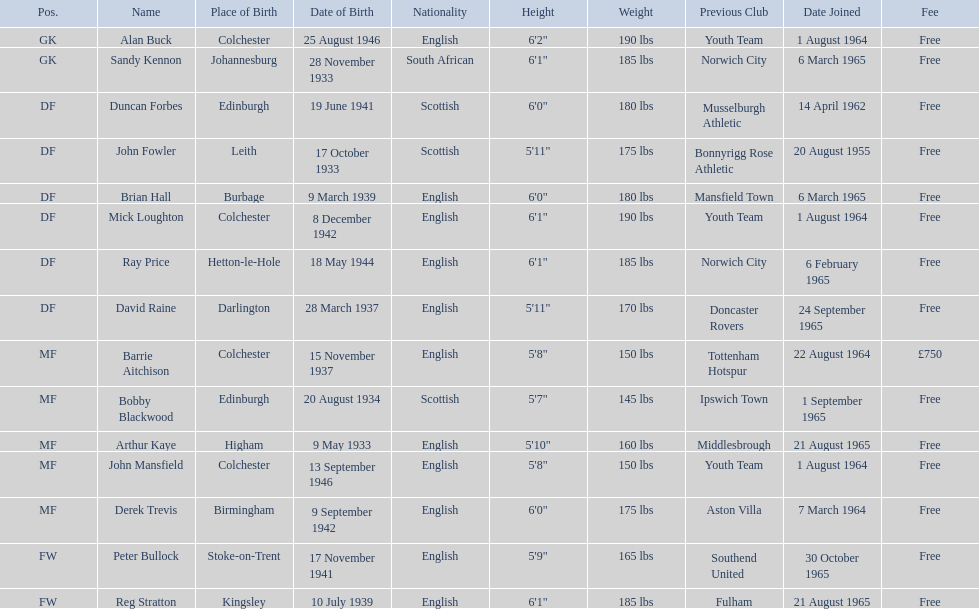Which player is the oldest? Arthur Kaye. Give me the full table as a dictionary. {'header': ['Pos.', 'Name', 'Place of Birth', 'Date of Birth', 'Nationality', 'Height', 'Weight', 'Previous Club', 'Date Joined', 'Fee'], 'rows': [['GK', 'Alan Buck', 'Colchester', '25 August 1946', 'English', '6\'2"', '190 lbs', 'Youth Team', '1 August 1964', 'Free'], ['GK', 'Sandy Kennon', 'Johannesburg', '28 November 1933', 'South African', '6\'1"', '185 lbs', 'Norwich City', '6 March 1965', 'Free'], ['DF', 'Duncan Forbes', 'Edinburgh', '19 June 1941', 'Scottish', '6\'0"', '180 lbs', 'Musselburgh Athletic', '14 April 1962', 'Free'], ['DF', 'John Fowler', 'Leith', '17 October 1933', 'Scottish', '5\'11"', '175 lbs', 'Bonnyrigg Rose Athletic', '20 August 1955', 'Free'], ['DF', 'Brian Hall', 'Burbage', '9 March 1939', 'English', '6\'0"', '180 lbs', 'Mansfield Town', '6 March 1965', 'Free'], ['DF', 'Mick Loughton', 'Colchester', '8 December 1942', 'English', '6\'1"', '190 lbs', 'Youth Team', '1 August 1964', 'Free'], ['DF', 'Ray Price', 'Hetton-le-Hole', '18 May 1944', 'English', '6\'1"', '185 lbs', 'Norwich City', '6 February 1965', 'Free'], ['DF', 'David Raine', 'Darlington', '28 March 1937', 'English', '5\'11"', '170 lbs', 'Doncaster Rovers', '24 September 1965', 'Free'], ['MF', 'Barrie Aitchison', 'Colchester', '15 November 1937', 'English', '5\'8"', '150 lbs', 'Tottenham Hotspur', '22 August 1964', '£750'], ['MF', 'Bobby Blackwood', 'Edinburgh', '20 August 1934', 'Scottish', '5\'7"', '145 lbs', 'Ipswich Town', '1 September 1965', 'Free'], ['MF', 'Arthur Kaye', 'Higham', '9 May 1933', 'English', '5\'10"', '160 lbs', 'Middlesbrough', '21 August 1965', 'Free'], ['MF', 'John Mansfield', 'Colchester', '13 September 1946', 'English', '5\'8"', '150 lbs', 'Youth Team', '1 August 1964', 'Free'], ['MF', 'Derek Trevis', 'Birmingham', '9 September 1942', 'English', '6\'0"', '175 lbs', 'Aston Villa', '7 March 1964', 'Free'], ['FW', 'Peter Bullock', 'Stoke-on-Trent', '17 November 1941', 'English', '5\'9"', '165 lbs', 'Southend United', '30 October 1965', 'Free'], ['FW', 'Reg Stratton', 'Kingsley', '10 July 1939', 'English', '6\'1"', '185 lbs', 'Fulham', '21 August 1965', 'Free']]} 